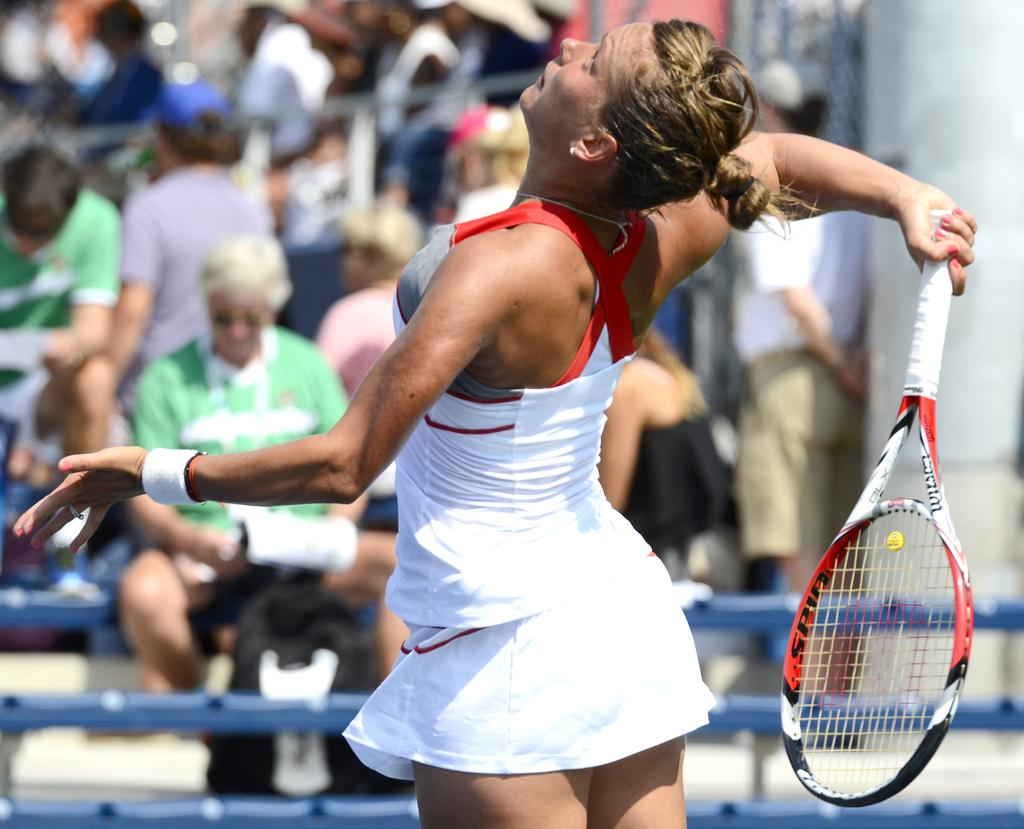What sport is the woman in the image participating in? The woman is playing tennis in the image. What equipment is the woman using to play tennis? The woman is using a tennis racket. Who is watching the tennis match in the image? There is an audience seated and watching the tennis match. Are there any other people present in the image besides the woman playing tennis and the audience? Yes, there are people standing in the image. What effect does the woman's tennis match have on her outstanding debt? There is no information about the woman's outstanding debt in the image, so it cannot be determined how the tennis match affects it. 